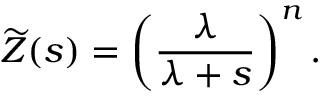Convert formula to latex. <formula><loc_0><loc_0><loc_500><loc_500>{ \widetilde { Z } } ( s ) = \left ( { \frac { \lambda } { \lambda + s } } \right ) ^ { n } .</formula> 